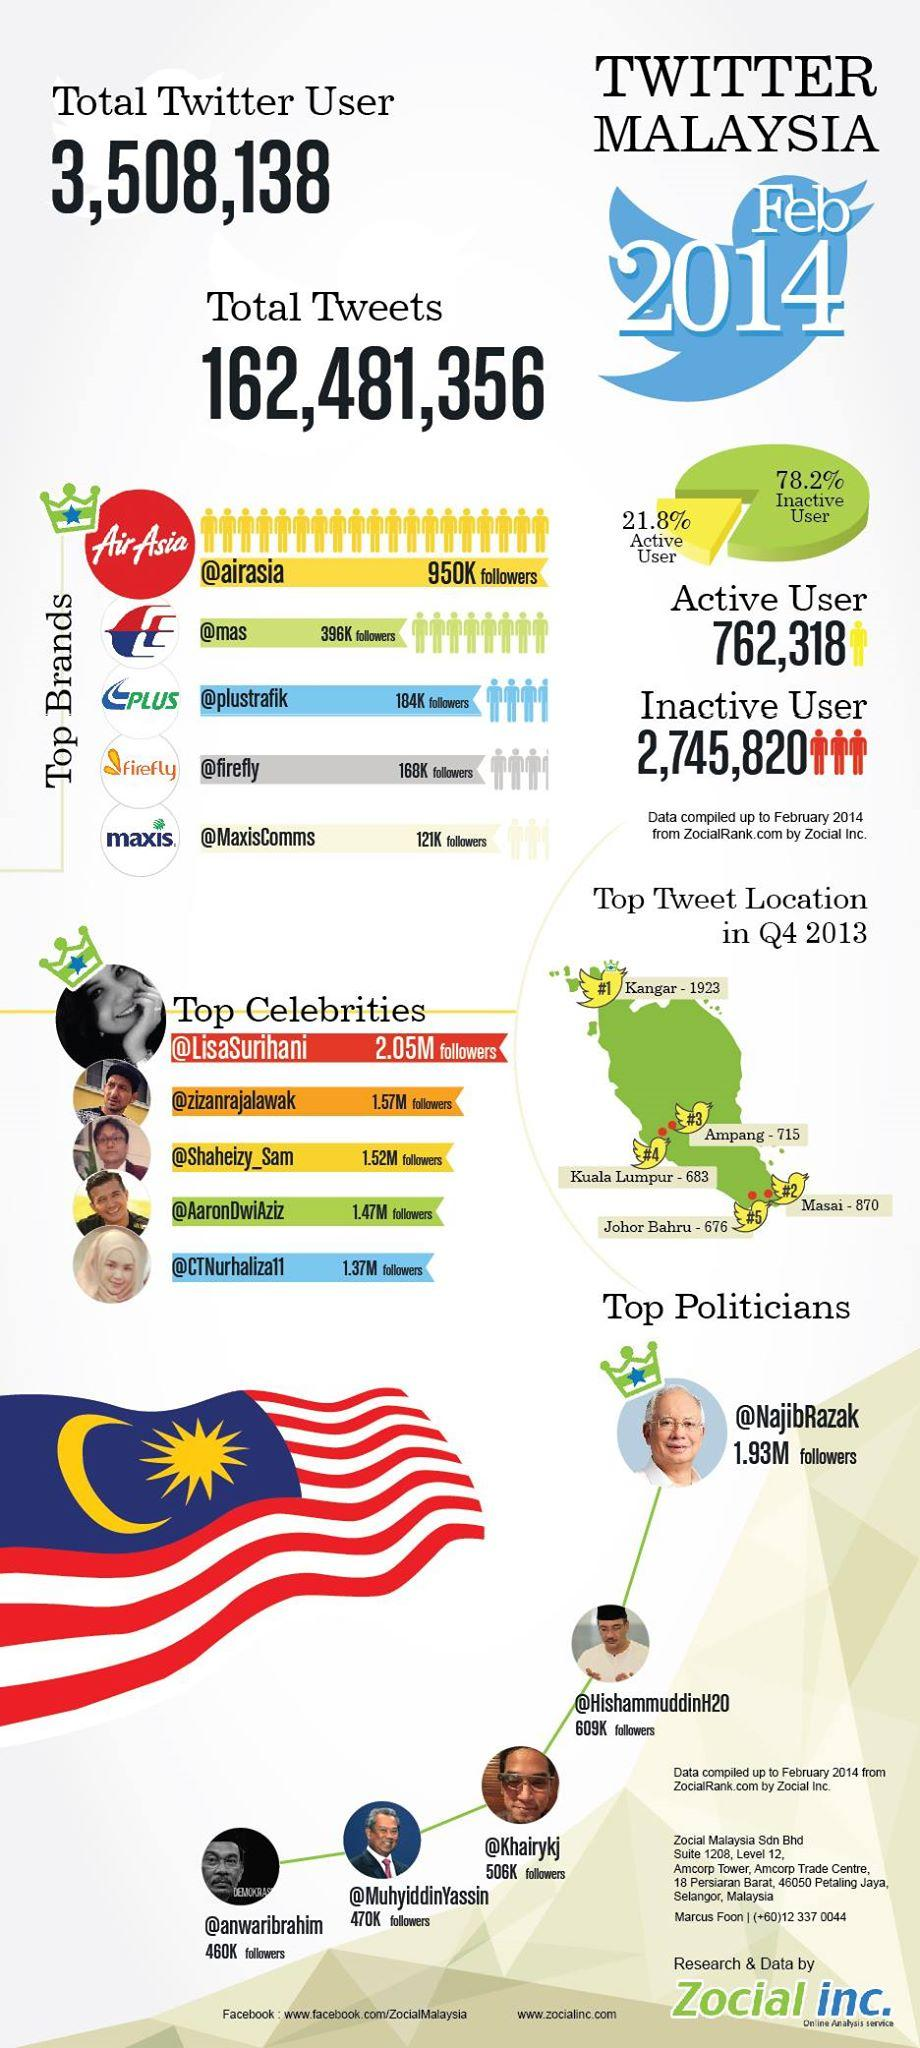Highlight a few significant elements in this photo. According to data, the third-most famous celebrity in Malaysia has approximately 1.52 million followers. The number of Malaysian Twitter users who are considered lazy is 2,745,820. The regular Twitter users prefer the color yellow. A total of 762,318 Malaysians are regular Twitter users, according to recent statistics. According to a survey conducted in Malaysia, the second-most favorite brand among the people is... 